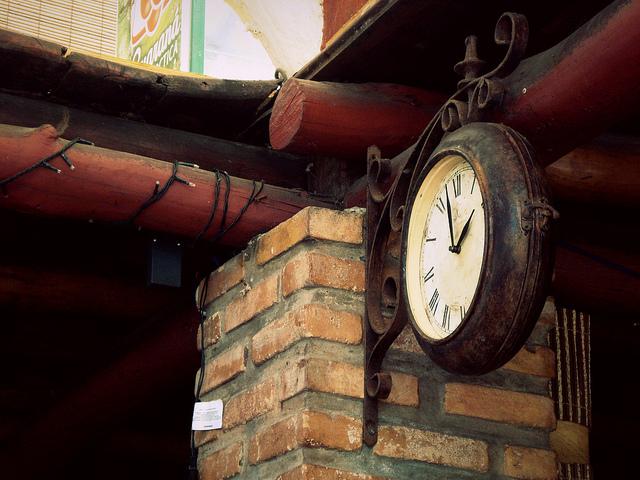Is the clock rusty?
Be succinct. Yes. What time is it?
Concise answer only. 2:00. What material is the clock mounted to?
Be succinct. Brick. 